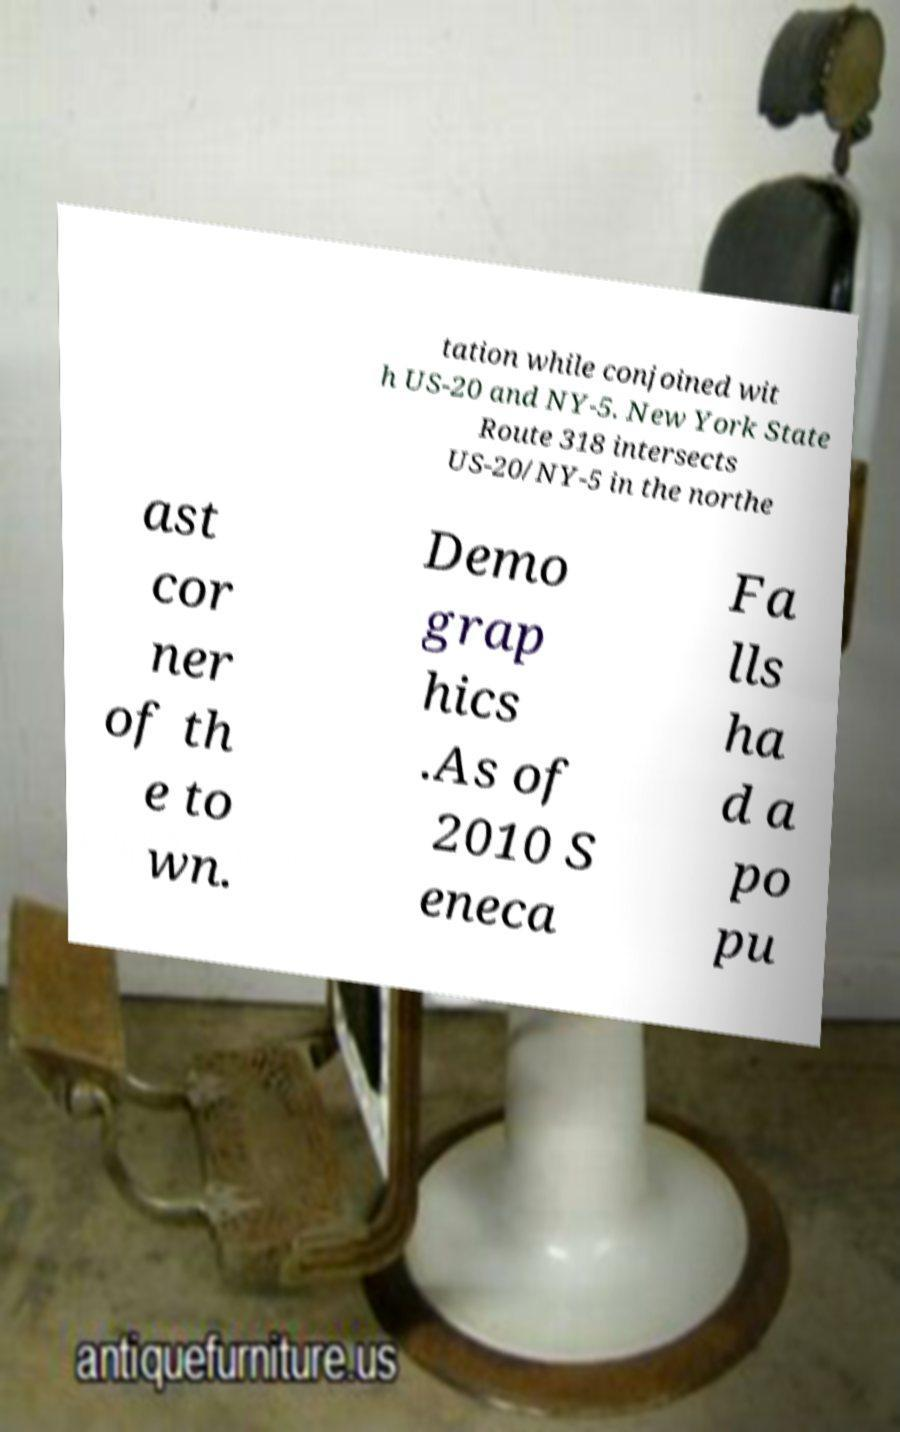Can you accurately transcribe the text from the provided image for me? tation while conjoined wit h US-20 and NY-5. New York State Route 318 intersects US-20/NY-5 in the northe ast cor ner of th e to wn. Demo grap hics .As of 2010 S eneca Fa lls ha d a po pu 